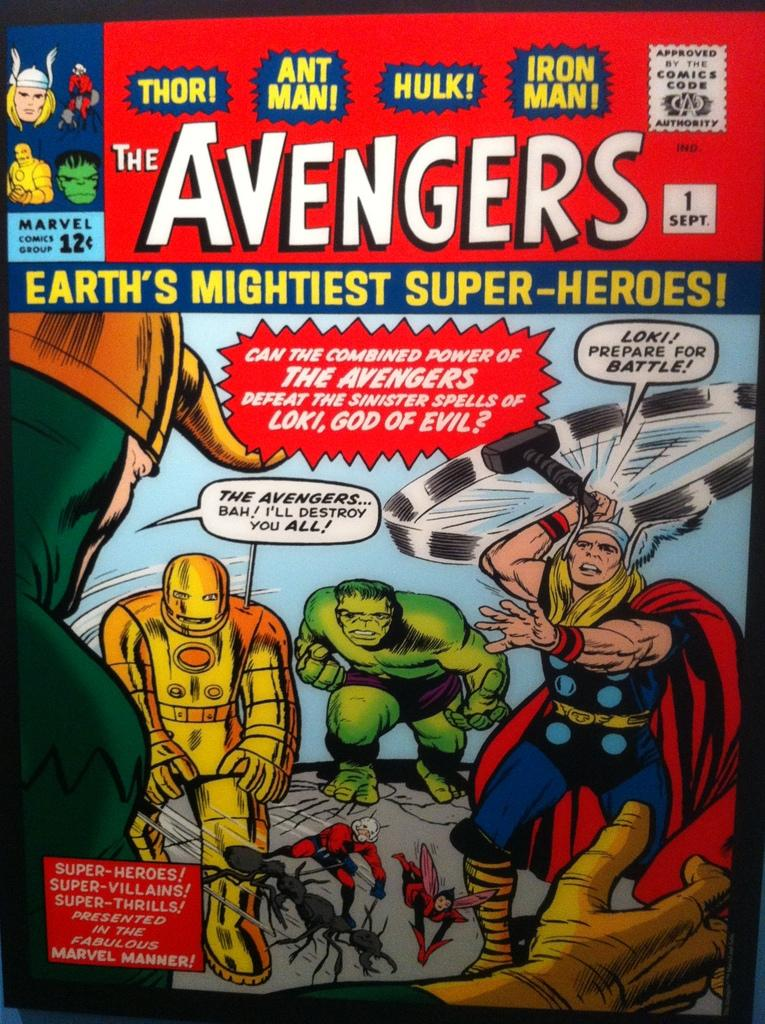<image>
Present a compact description of the photo's key features. A copy of The Avengers comic book published September 1st. 